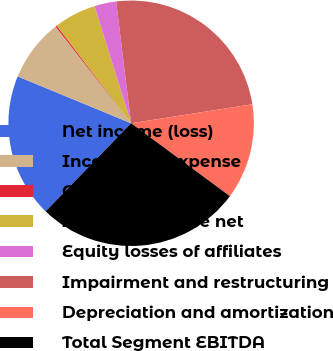Convert chart. <chart><loc_0><loc_0><loc_500><loc_500><pie_chart><fcel>Net income (loss)<fcel>Income tax expense<fcel>Other net<fcel>Interest expense net<fcel>Equity losses of affiliates<fcel>Impairment and restructuring<fcel>Depreciation and amortization<fcel>Total Segment EBITDA<nl><fcel>18.97%<fcel>8.21%<fcel>0.2%<fcel>5.54%<fcel>2.87%<fcel>24.47%<fcel>12.6%<fcel>27.14%<nl></chart> 